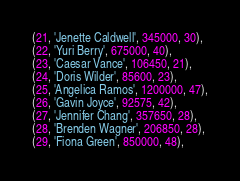<code> <loc_0><loc_0><loc_500><loc_500><_SQL_>(21, 'Jenette Caldwell', 345000, 30),
(22, 'Yuri Berry', 675000, 40),
(23, 'Caesar Vance', 106450, 21),
(24, 'Doris Wilder', 85600, 23),
(25, 'Angelica Ramos', 1200000, 47),
(26, 'Gavin Joyce', 92575, 42),
(27, 'Jennifer Chang', 357650, 28),
(28, 'Brenden Wagner', 206850, 28),
(29, 'Fiona Green', 850000, 48),</code> 